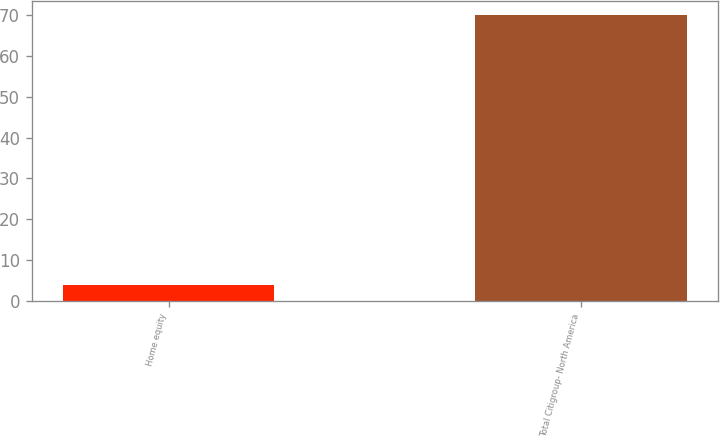<chart> <loc_0><loc_0><loc_500><loc_500><bar_chart><fcel>Home equity<fcel>Total Citigroup- North America<nl><fcel>4<fcel>70<nl></chart> 